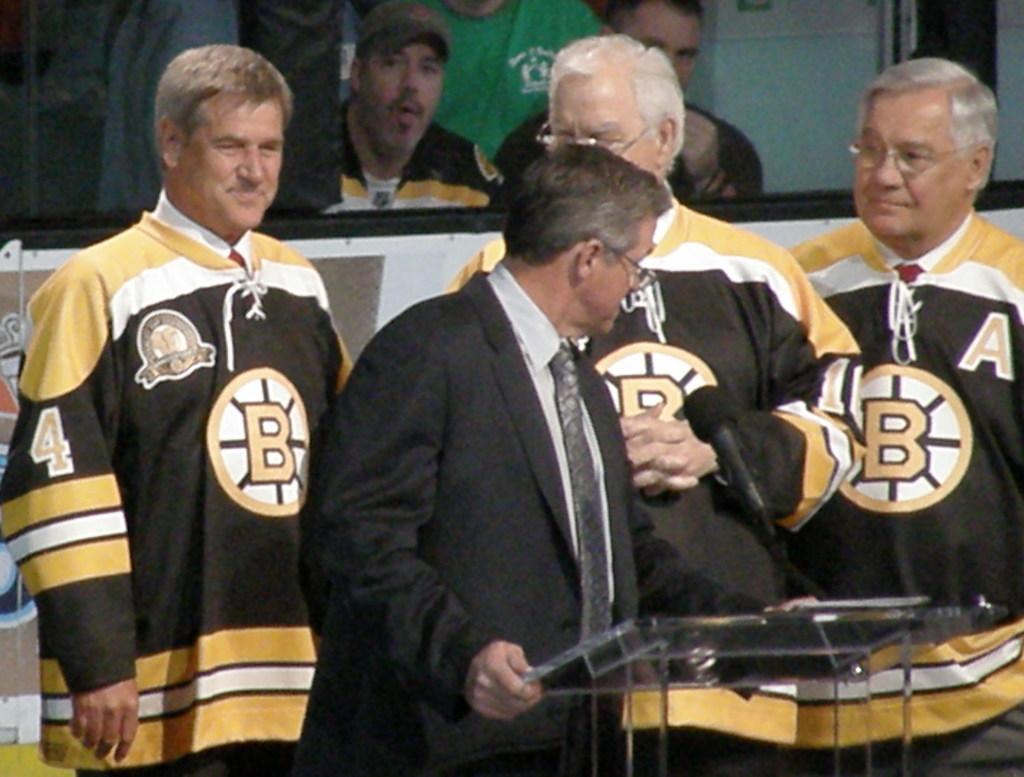What letter appears on the men's jerseys?
Offer a terse response. B. Are the jerseys from the bruins?
Ensure brevity in your answer.  Yes. 